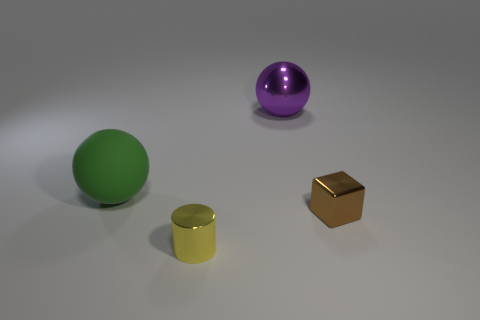How many metal spheres are the same size as the yellow cylinder?
Offer a very short reply. 0. Are there fewer big green spheres right of the small yellow cylinder than small cylinders that are behind the brown object?
Keep it short and to the point. No. What number of matte things are either red cubes or tiny brown blocks?
Your answer should be compact. 0. What shape is the purple object?
Your response must be concise. Sphere. There is a purple object that is the same size as the green object; what is its material?
Provide a succinct answer. Metal. How many large things are either rubber things or cyan metal objects?
Offer a very short reply. 1. Are there any small brown cubes?
Ensure brevity in your answer.  Yes. The purple sphere that is made of the same material as the tiny brown cube is what size?
Offer a very short reply. Large. Is the small brown block made of the same material as the yellow object?
Provide a succinct answer. Yes. What number of other things are there of the same material as the big green ball
Your answer should be compact. 0. 